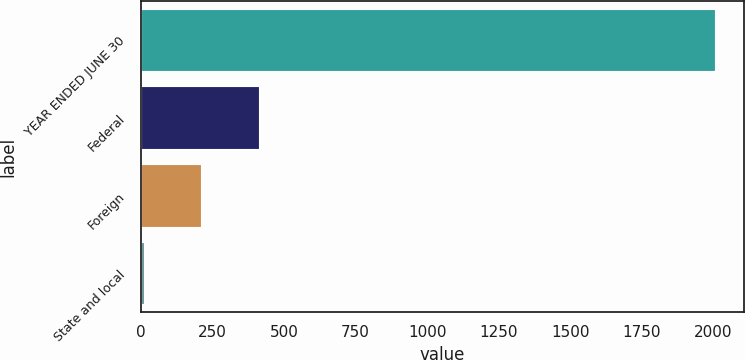<chart> <loc_0><loc_0><loc_500><loc_500><bar_chart><fcel>YEAR ENDED JUNE 30<fcel>Federal<fcel>Foreign<fcel>State and local<nl><fcel>2006<fcel>410.4<fcel>210.95<fcel>11.5<nl></chart> 